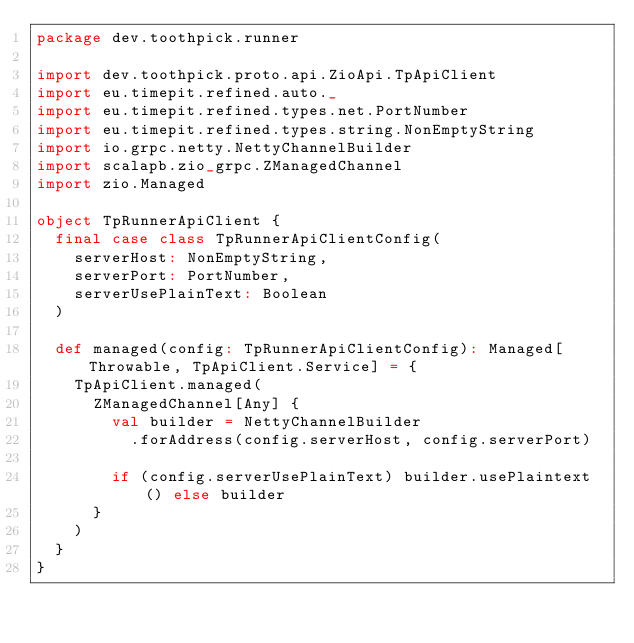Convert code to text. <code><loc_0><loc_0><loc_500><loc_500><_Scala_>package dev.toothpick.runner

import dev.toothpick.proto.api.ZioApi.TpApiClient
import eu.timepit.refined.auto._
import eu.timepit.refined.types.net.PortNumber
import eu.timepit.refined.types.string.NonEmptyString
import io.grpc.netty.NettyChannelBuilder
import scalapb.zio_grpc.ZManagedChannel
import zio.Managed

object TpRunnerApiClient {
  final case class TpRunnerApiClientConfig(
    serverHost: NonEmptyString,
    serverPort: PortNumber,
    serverUsePlainText: Boolean
  )

  def managed(config: TpRunnerApiClientConfig): Managed[Throwable, TpApiClient.Service] = {
    TpApiClient.managed(
      ZManagedChannel[Any] {
        val builder = NettyChannelBuilder
          .forAddress(config.serverHost, config.serverPort)

        if (config.serverUsePlainText) builder.usePlaintext() else builder
      }
    )
  }
}
</code> 